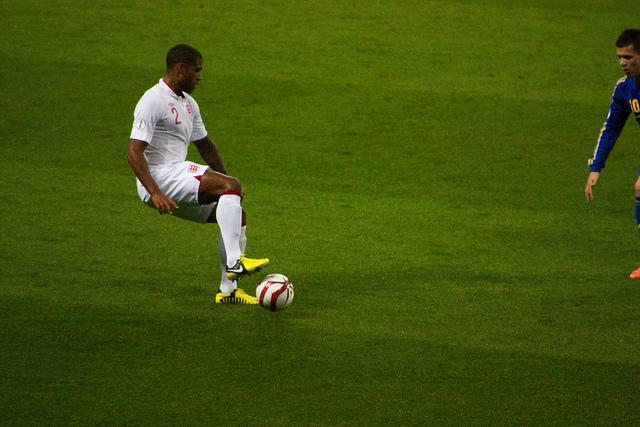How many people are in the photo?
Give a very brief answer. 2. 